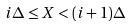Convert formula to latex. <formula><loc_0><loc_0><loc_500><loc_500>i \Delta \leq X < ( i + 1 ) \Delta</formula> 